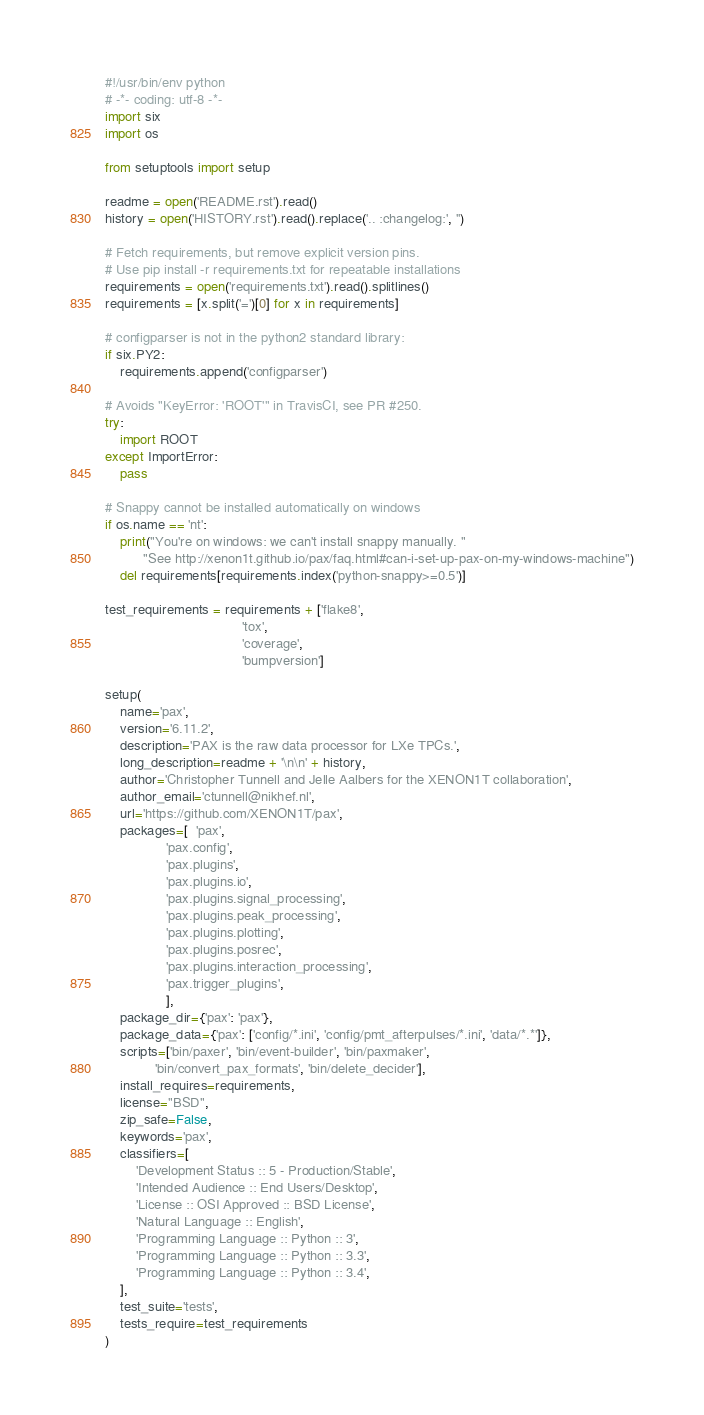<code> <loc_0><loc_0><loc_500><loc_500><_Python_>#!/usr/bin/env python
# -*- coding: utf-8 -*-
import six
import os

from setuptools import setup

readme = open('README.rst').read()
history = open('HISTORY.rst').read().replace('.. :changelog:', '')

# Fetch requirements, but remove explicit version pins.
# Use pip install -r requirements.txt for repeatable installations
requirements = open('requirements.txt').read().splitlines()
requirements = [x.split('=')[0] for x in requirements]

# configparser is not in the python2 standard library:
if six.PY2:
    requirements.append('configparser')

# Avoids "KeyError: 'ROOT'" in TravisCI, see PR #250.
try:
    import ROOT
except ImportError:
    pass

# Snappy cannot be installed automatically on windows
if os.name == 'nt':
    print("You're on windows: we can't install snappy manually. "
          "See http://xenon1t.github.io/pax/faq.html#can-i-set-up-pax-on-my-windows-machine")
    del requirements[requirements.index('python-snappy>=0.5')]

test_requirements = requirements + ['flake8',
                                    'tox',
                                    'coverage',
                                    'bumpversion']

setup(
    name='pax',
    version='6.11.2',
    description='PAX is the raw data processor for LXe TPCs.',
    long_description=readme + '\n\n' + history,
    author='Christopher Tunnell and Jelle Aalbers for the XENON1T collaboration',
    author_email='ctunnell@nikhef.nl',
    url='https://github.com/XENON1T/pax',
    packages=[  'pax',
                'pax.config',
                'pax.plugins',
                'pax.plugins.io',
                'pax.plugins.signal_processing',
                'pax.plugins.peak_processing',
                'pax.plugins.plotting',
                'pax.plugins.posrec',
                'pax.plugins.interaction_processing',
                'pax.trigger_plugins',
                ],
    package_dir={'pax': 'pax'},
    package_data={'pax': ['config/*.ini', 'config/pmt_afterpulses/*.ini', 'data/*.*']},
    scripts=['bin/paxer', 'bin/event-builder', 'bin/paxmaker',
             'bin/convert_pax_formats', 'bin/delete_decider'],
    install_requires=requirements,
    license="BSD",
    zip_safe=False,
    keywords='pax',
    classifiers=[
        'Development Status :: 5 - Production/Stable',
        'Intended Audience :: End Users/Desktop',
        'License :: OSI Approved :: BSD License',
        'Natural Language :: English',
        'Programming Language :: Python :: 3',
        'Programming Language :: Python :: 3.3',
        'Programming Language :: Python :: 3.4',
    ],
    test_suite='tests',
    tests_require=test_requirements
)
</code> 